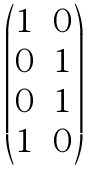Convert formula to latex. <formula><loc_0><loc_0><loc_500><loc_500>\begin{pmatrix} 1 & 0 \\ 0 & 1 \\ 0 & 1 \\ 1 & 0 \end{pmatrix}</formula> 